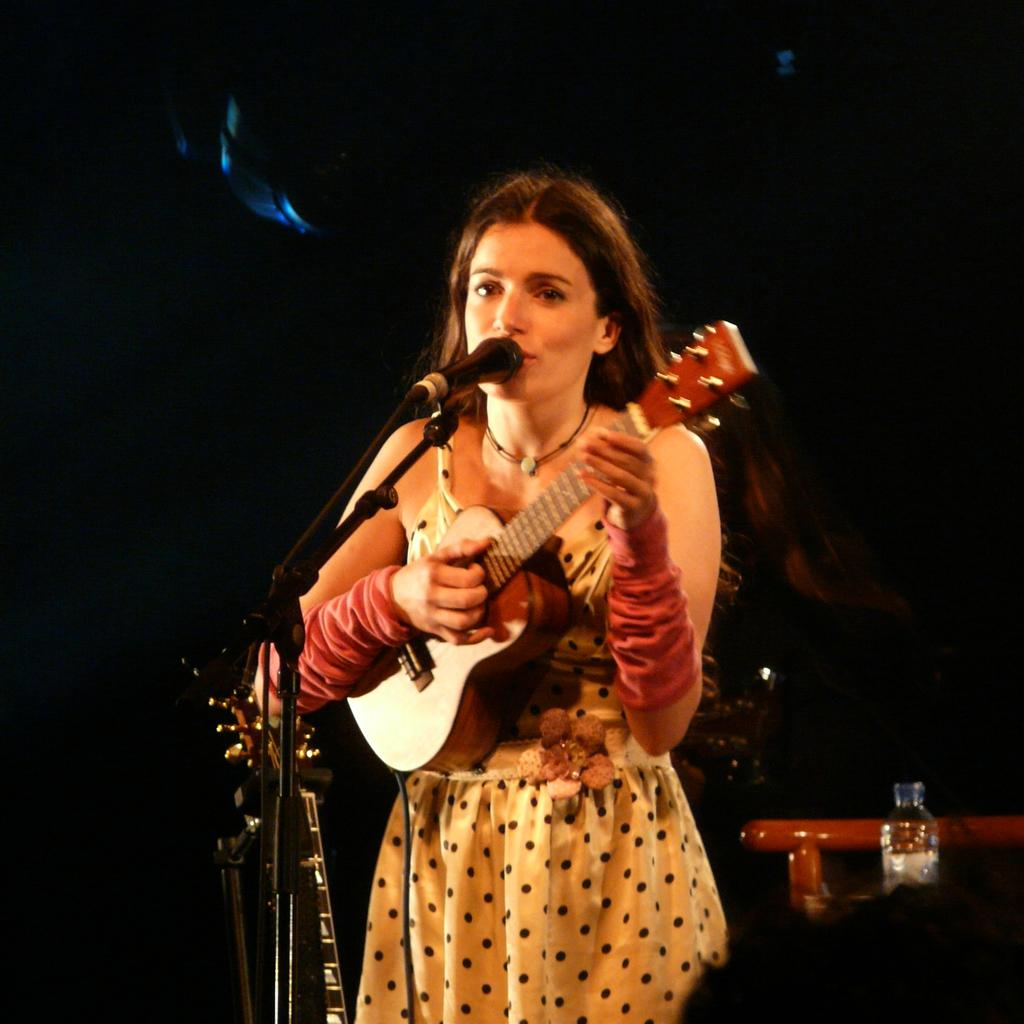What is the woman in the image holding? The woman is holding a guitar. What object is present in the image that is typically used for amplifying sound? There is a microphone in the image. What can be seen in the image that might be used to support or display something? There is a stand in the image. What type of shoe is the woman wearing in the image? There is no shoe visible in the image, as the woman is not shown from the feet up. 